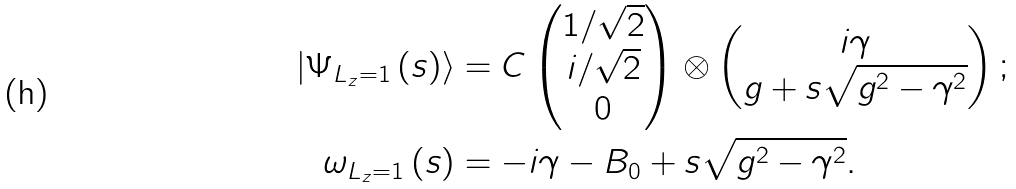Convert formula to latex. <formula><loc_0><loc_0><loc_500><loc_500>\left | \Psi _ { L _ { z } = 1 } \left ( s \right ) \right \rangle & = C \begin{pmatrix} 1 / \sqrt { 2 } \\ i / \sqrt { 2 } \\ 0 \end{pmatrix} \otimes \begin{pmatrix} i \gamma \\ g + s \sqrt { g ^ { 2 } - \gamma ^ { 2 } } \end{pmatrix} ; \\ \omega _ { L _ { z } = 1 } \left ( s \right ) & = - i \gamma - B _ { 0 } + s \sqrt { g ^ { 2 } - \gamma ^ { 2 } } .</formula> 